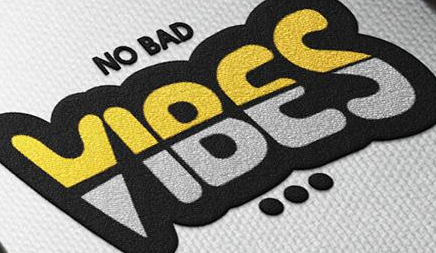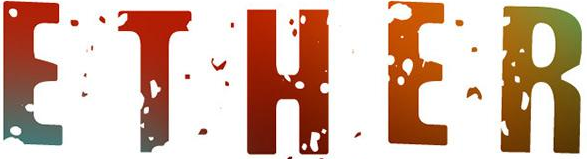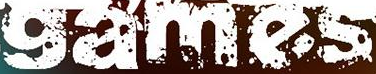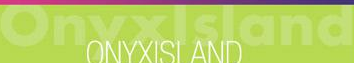What text appears in these images from left to right, separated by a semicolon? VIBES; ETHER; games; Onyxlsland 